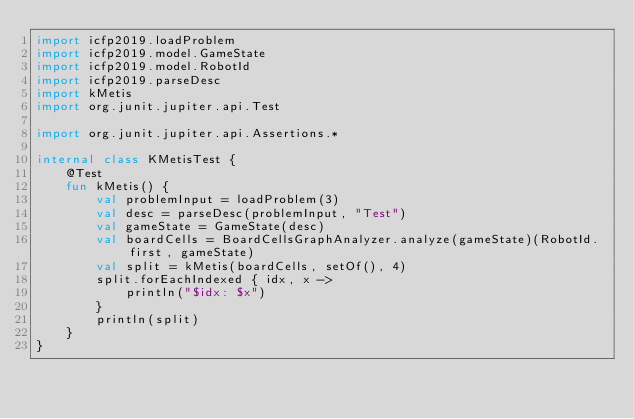<code> <loc_0><loc_0><loc_500><loc_500><_Kotlin_>import icfp2019.loadProblem
import icfp2019.model.GameState
import icfp2019.model.RobotId
import icfp2019.parseDesc
import kMetis
import org.junit.jupiter.api.Test

import org.junit.jupiter.api.Assertions.*

internal class KMetisTest {
    @Test
    fun kMetis() {
        val problemInput = loadProblem(3)
        val desc = parseDesc(problemInput, "Test")
        val gameState = GameState(desc)
        val boardCells = BoardCellsGraphAnalyzer.analyze(gameState)(RobotId.first, gameState)
        val split = kMetis(boardCells, setOf(), 4)
        split.forEachIndexed { idx, x ->
            println("$idx: $x")
        }
        println(split)
    }
}
</code> 